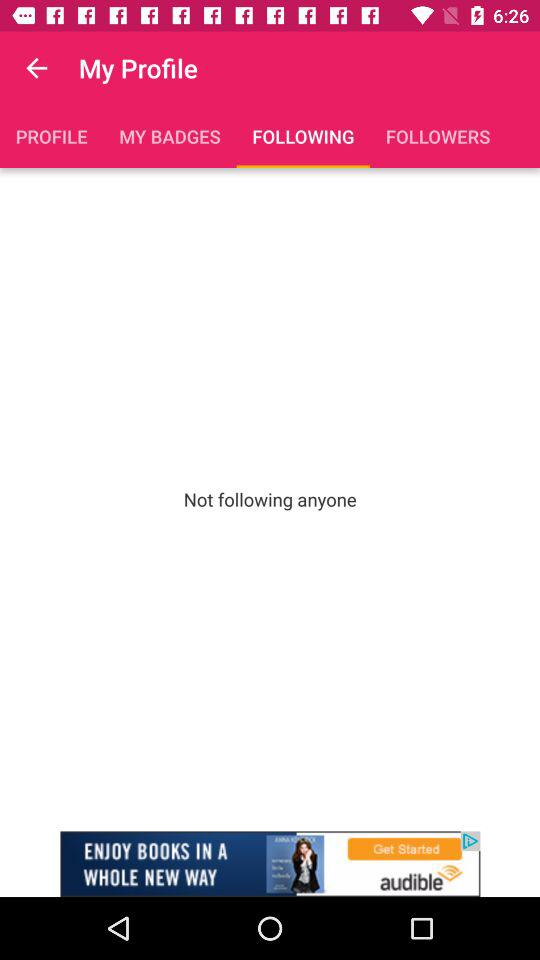How many people is the user not following?
Answer the question using a single word or phrase. 0 